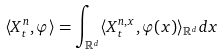Convert formula to latex. <formula><loc_0><loc_0><loc_500><loc_500>\langle X _ { t } ^ { n } , \varphi \rangle = \int _ { \mathbb { R } ^ { d } } \langle X _ { t } ^ { n , x } , \varphi ( x ) \rangle _ { \mathbb { R } ^ { d } } d x</formula> 